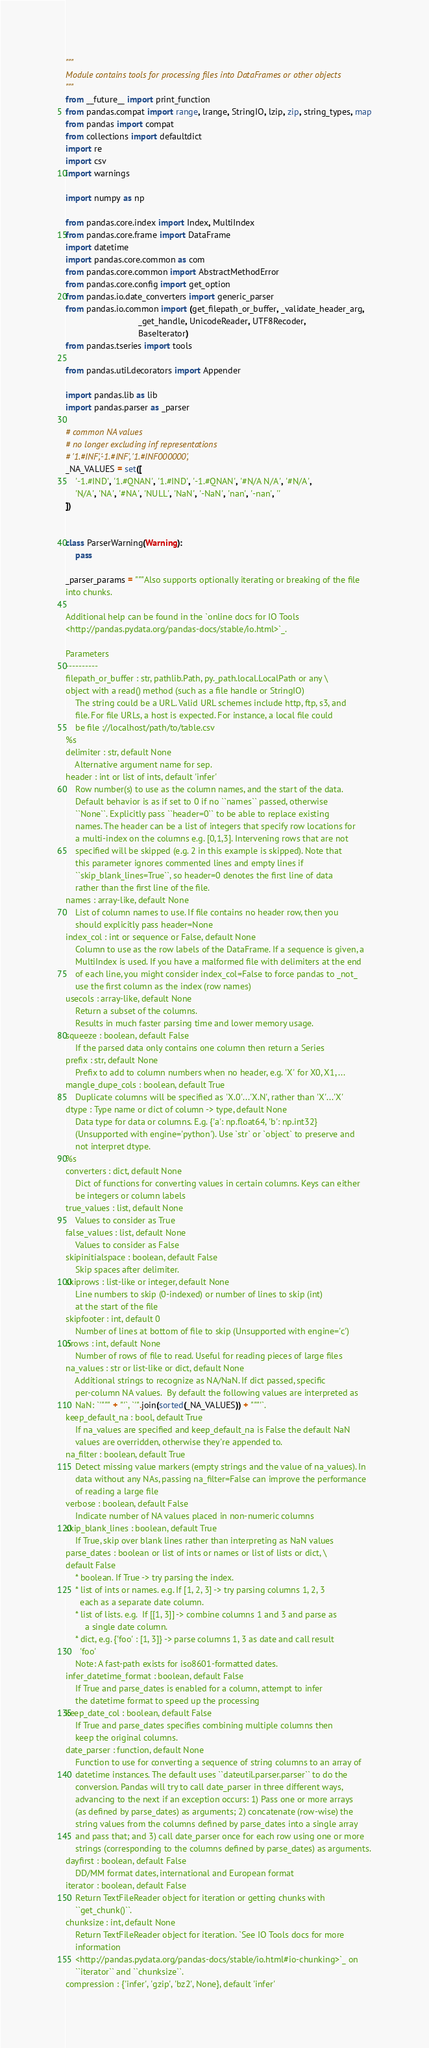Convert code to text. <code><loc_0><loc_0><loc_500><loc_500><_Python_>"""
Module contains tools for processing files into DataFrames or other objects
"""
from __future__ import print_function
from pandas.compat import range, lrange, StringIO, lzip, zip, string_types, map
from pandas import compat
from collections import defaultdict
import re
import csv
import warnings

import numpy as np

from pandas.core.index import Index, MultiIndex
from pandas.core.frame import DataFrame
import datetime
import pandas.core.common as com
from pandas.core.common import AbstractMethodError
from pandas.core.config import get_option
from pandas.io.date_converters import generic_parser
from pandas.io.common import (get_filepath_or_buffer, _validate_header_arg,
                              _get_handle, UnicodeReader, UTF8Recoder,
                              BaseIterator)
from pandas.tseries import tools

from pandas.util.decorators import Appender

import pandas.lib as lib
import pandas.parser as _parser

# common NA values
# no longer excluding inf representations
# '1.#INF','-1.#INF', '1.#INF000000',
_NA_VALUES = set([
    '-1.#IND', '1.#QNAN', '1.#IND', '-1.#QNAN', '#N/A N/A', '#N/A',
    'N/A', 'NA', '#NA', 'NULL', 'NaN', '-NaN', 'nan', '-nan', ''
])


class ParserWarning(Warning):
    pass

_parser_params = """Also supports optionally iterating or breaking of the file
into chunks.

Additional help can be found in the `online docs for IO Tools
<http://pandas.pydata.org/pandas-docs/stable/io.html>`_.

Parameters
----------
filepath_or_buffer : str, pathlib.Path, py._path.local.LocalPath or any \
object with a read() method (such as a file handle or StringIO)
    The string could be a URL. Valid URL schemes include http, ftp, s3, and
    file. For file URLs, a host is expected. For instance, a local file could
    be file ://localhost/path/to/table.csv
%s
delimiter : str, default None
    Alternative argument name for sep.
header : int or list of ints, default 'infer'
    Row number(s) to use as the column names, and the start of the data.
    Default behavior is as if set to 0 if no ``names`` passed, otherwise
    ``None``. Explicitly pass ``header=0`` to be able to replace existing
    names. The header can be a list of integers that specify row locations for
    a multi-index on the columns e.g. [0,1,3]. Intervening rows that are not
    specified will be skipped (e.g. 2 in this example is skipped). Note that
    this parameter ignores commented lines and empty lines if
    ``skip_blank_lines=True``, so header=0 denotes the first line of data
    rather than the first line of the file.
names : array-like, default None
    List of column names to use. If file contains no header row, then you
    should explicitly pass header=None
index_col : int or sequence or False, default None
    Column to use as the row labels of the DataFrame. If a sequence is given, a
    MultiIndex is used. If you have a malformed file with delimiters at the end
    of each line, you might consider index_col=False to force pandas to _not_
    use the first column as the index (row names)
usecols : array-like, default None
    Return a subset of the columns.
    Results in much faster parsing time and lower memory usage.
squeeze : boolean, default False
    If the parsed data only contains one column then return a Series
prefix : str, default None
    Prefix to add to column numbers when no header, e.g. 'X' for X0, X1, ...
mangle_dupe_cols : boolean, default True
    Duplicate columns will be specified as 'X.0'...'X.N', rather than 'X'...'X'
dtype : Type name or dict of column -> type, default None
    Data type for data or columns. E.g. {'a': np.float64, 'b': np.int32}
    (Unsupported with engine='python'). Use `str` or `object` to preserve and
    not interpret dtype.
%s
converters : dict, default None
    Dict of functions for converting values in certain columns. Keys can either
    be integers or column labels
true_values : list, default None
    Values to consider as True
false_values : list, default None
    Values to consider as False
skipinitialspace : boolean, default False
    Skip spaces after delimiter.
skiprows : list-like or integer, default None
    Line numbers to skip (0-indexed) or number of lines to skip (int)
    at the start of the file
skipfooter : int, default 0
    Number of lines at bottom of file to skip (Unsupported with engine='c')
nrows : int, default None
    Number of rows of file to read. Useful for reading pieces of large files
na_values : str or list-like or dict, default None
    Additional strings to recognize as NA/NaN. If dict passed, specific
    per-column NA values.  By default the following values are interpreted as
    NaN: `'""" + "'`, `'".join(sorted(_NA_VALUES)) + """'`.
keep_default_na : bool, default True
    If na_values are specified and keep_default_na is False the default NaN
    values are overridden, otherwise they're appended to.
na_filter : boolean, default True
    Detect missing value markers (empty strings and the value of na_values). In
    data without any NAs, passing na_filter=False can improve the performance
    of reading a large file
verbose : boolean, default False
    Indicate number of NA values placed in non-numeric columns
skip_blank_lines : boolean, default True
    If True, skip over blank lines rather than interpreting as NaN values
parse_dates : boolean or list of ints or names or list of lists or dict, \
default False
    * boolean. If True -> try parsing the index.
    * list of ints or names. e.g. If [1, 2, 3] -> try parsing columns 1, 2, 3
      each as a separate date column.
    * list of lists. e.g.  If [[1, 3]] -> combine columns 1 and 3 and parse as
        a single date column.
    * dict, e.g. {'foo' : [1, 3]} -> parse columns 1, 3 as date and call result
      'foo'
    Note: A fast-path exists for iso8601-formatted dates.
infer_datetime_format : boolean, default False
    If True and parse_dates is enabled for a column, attempt to infer
    the datetime format to speed up the processing
keep_date_col : boolean, default False
    If True and parse_dates specifies combining multiple columns then
    keep the original columns.
date_parser : function, default None
    Function to use for converting a sequence of string columns to an array of
    datetime instances. The default uses ``dateutil.parser.parser`` to do the
    conversion. Pandas will try to call date_parser in three different ways,
    advancing to the next if an exception occurs: 1) Pass one or more arrays
    (as defined by parse_dates) as arguments; 2) concatenate (row-wise) the
    string values from the columns defined by parse_dates into a single array
    and pass that; and 3) call date_parser once for each row using one or more
    strings (corresponding to the columns defined by parse_dates) as arguments.
dayfirst : boolean, default False
    DD/MM format dates, international and European format
iterator : boolean, default False
    Return TextFileReader object for iteration or getting chunks with
    ``get_chunk()``.
chunksize : int, default None
    Return TextFileReader object for iteration. `See IO Tools docs for more
    information
    <http://pandas.pydata.org/pandas-docs/stable/io.html#io-chunking>`_ on
    ``iterator`` and ``chunksize``.
compression : {'infer', 'gzip', 'bz2', None}, default 'infer'</code> 